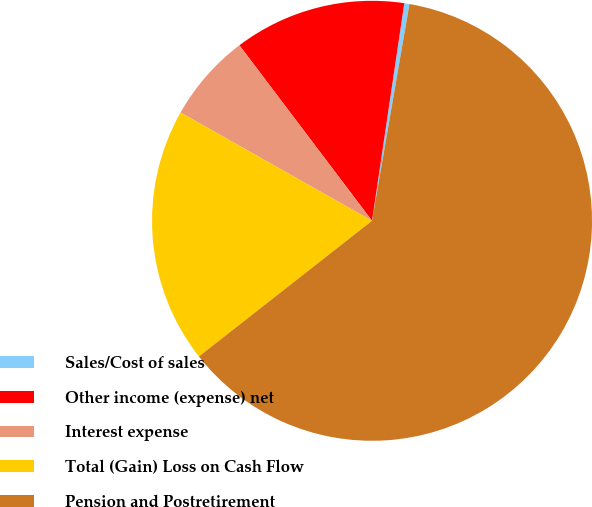<chart> <loc_0><loc_0><loc_500><loc_500><pie_chart><fcel>Sales/Cost of sales<fcel>Other income (expense) net<fcel>Interest expense<fcel>Total (Gain) Loss on Cash Flow<fcel>Pension and Postretirement<nl><fcel>0.38%<fcel>12.64%<fcel>6.51%<fcel>18.77%<fcel>61.69%<nl></chart> 